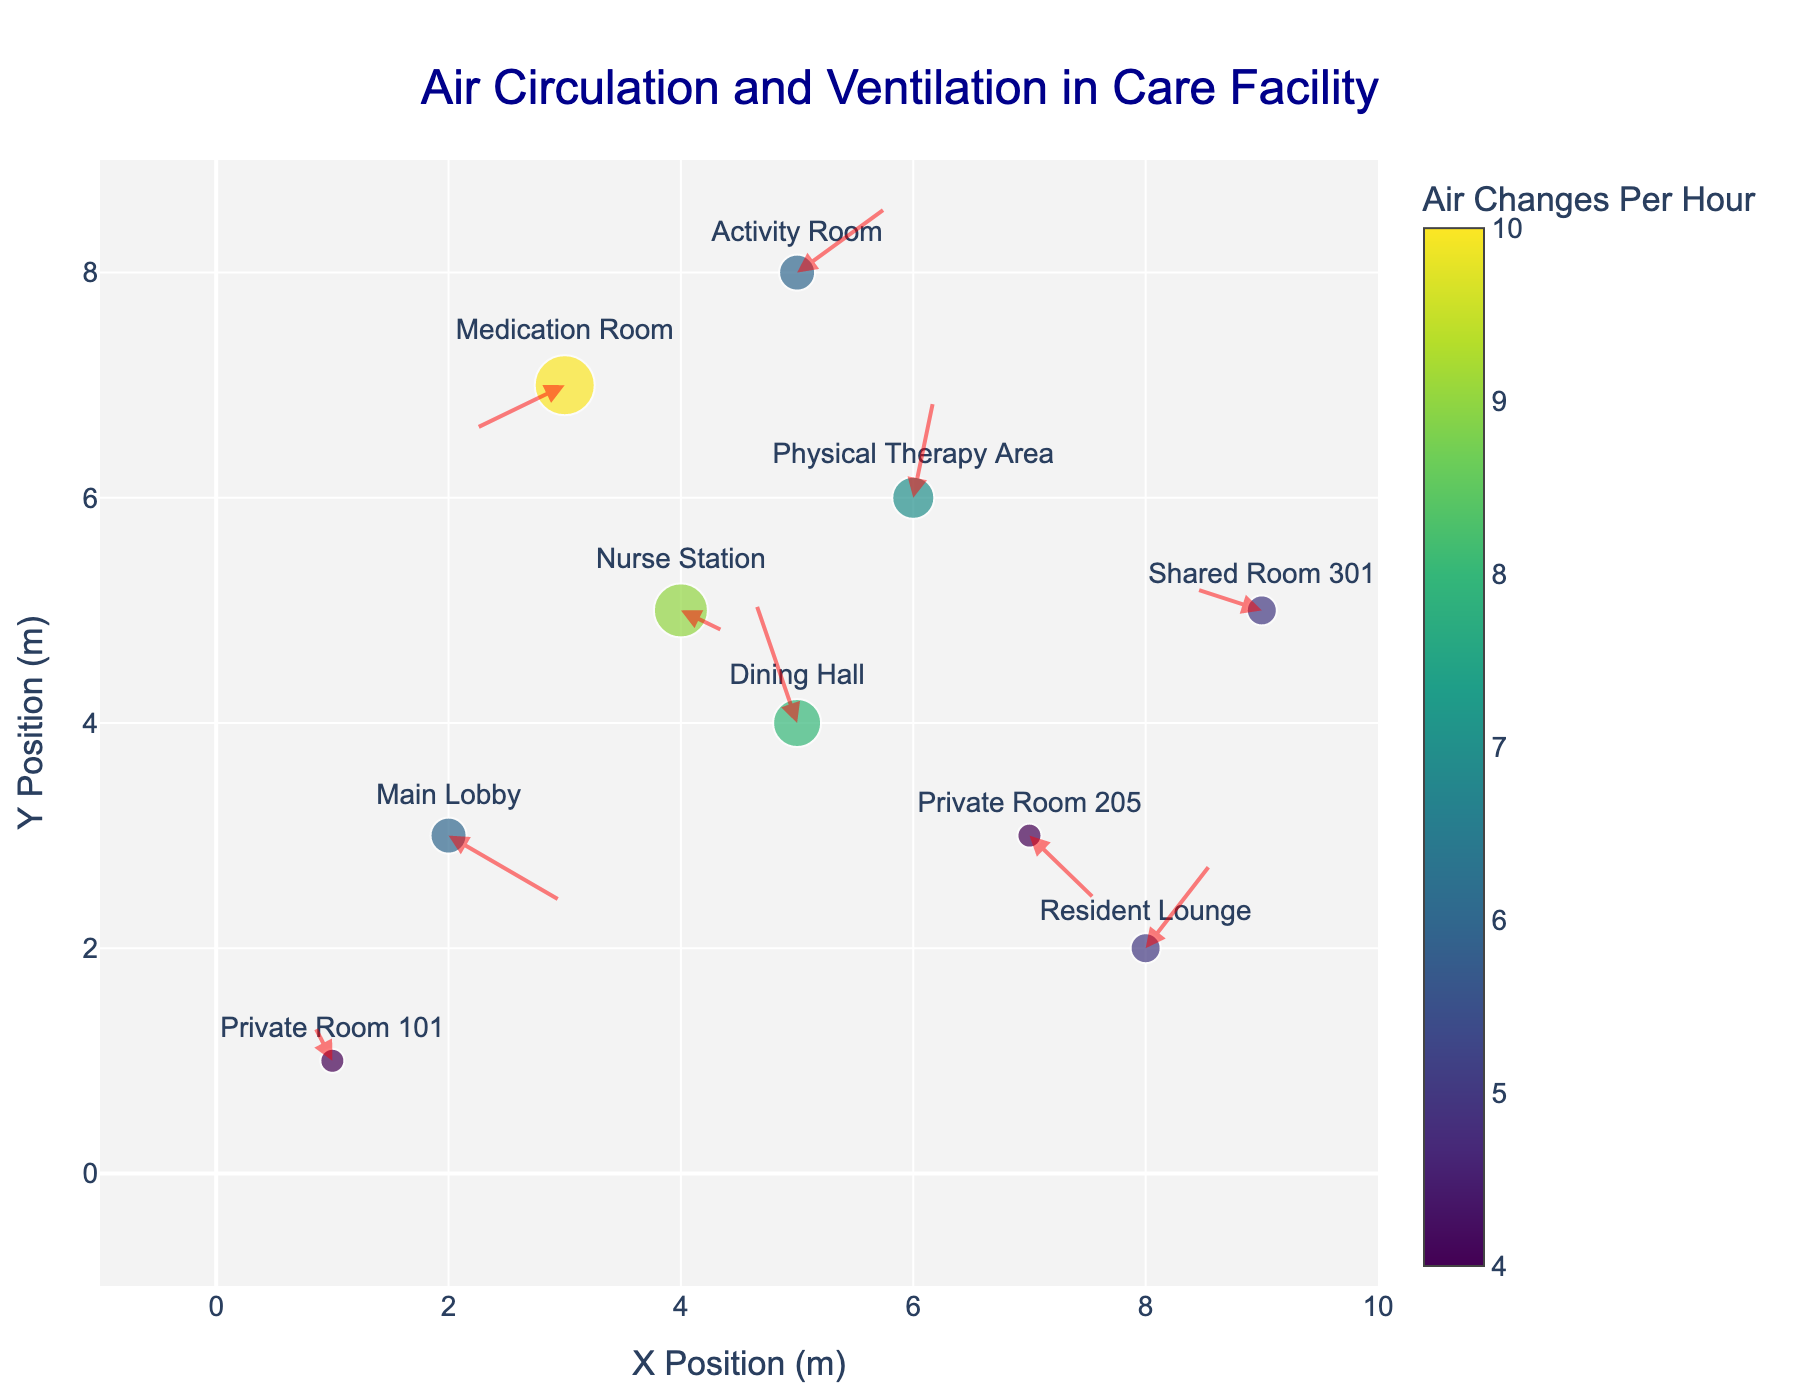How many rooms are depicted in the figure? To determine the number of rooms, count the unique labels representing rooms in the figure. The quiver plot shows 10 unique room names.
Answer: 10 Which room has the highest air changes per hour? This can be determined by identifying the room with the largest marker, as marker size represents air changes per hour. The "Medication Room" has the largest marker.
Answer: Medication Room What is the air velocity in the Dining Hall? Look at the arrow originating from the Dining Hall marker. The hover text on the marker provides the air velocity, which is (-0.2, 0.6).
Answer: (-0.2, 0.6) Which room has a negative air velocity in both X and Y directions? Check the hover text for each room’s marker for air velocities and identify the room where both components are negative. The "Medication Room" fits this description.
Answer: Medication Room Compare the air changes per hour in the Resident Lounge and the Nurse Station. Which one is higher? Look at the marker sizes or hover over the markers and compare the air changes indicated in the hover text: Resident Lounge has 5, and Nurse Station has 9. The Nurse Station is higher.
Answer: Nurse Station Calculate the average air changes per hour across all rooms. Sum the air changes per hour for all rooms and divide by the total number of rooms: (6 + 8 + 5 + 10 + 7 + 9 + 4 + 4 + 5 + 6) / 10 = 64 / 10 = 6.4.
Answer: 6.4 Which rooms share the same air changes per hour value? Identify rooms with identical marker sizes or values shown in the hover text. "Resident Lounge" and "Shared Room 301" both have 5; "Private Room 101" and "Private Room 205" both have 4.
Answer: Resident Lounge and Shared Room 301; Private Room 101 and Private Room 205 Is there any room with zero air velocity? Check the hover text of each room for velocities (vx, vy). None of the rooms show (0, 0) for air velocity.
Answer: No Which rooms have an air velocity X component greater than 0.3? Check the hover text for each room's air velocities; "Resident Lounge" and "Activity Room" have an air velocity X component greater than 0.3.
Answer: Resident Lounge and Activity Room What is the minimum and maximum Y position of the rooms? Look at the Y-axis values of the room positions; the minimum Y position is 1 (Private Room 101), and the maximum Y position is 8 (Medication Room, Activity Room).
Answer: 1, 8 